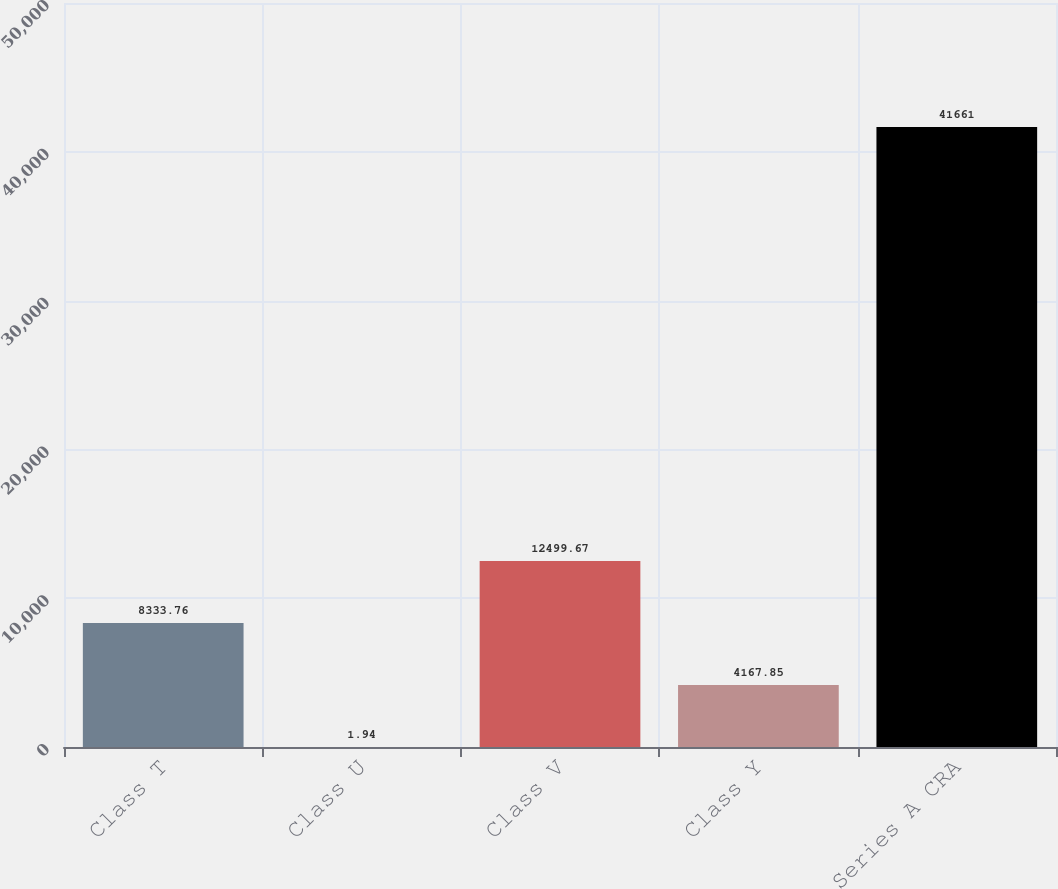Convert chart. <chart><loc_0><loc_0><loc_500><loc_500><bar_chart><fcel>Class T<fcel>Class U<fcel>Class V<fcel>Class Y<fcel>Series A CRA<nl><fcel>8333.76<fcel>1.94<fcel>12499.7<fcel>4167.85<fcel>41661<nl></chart> 